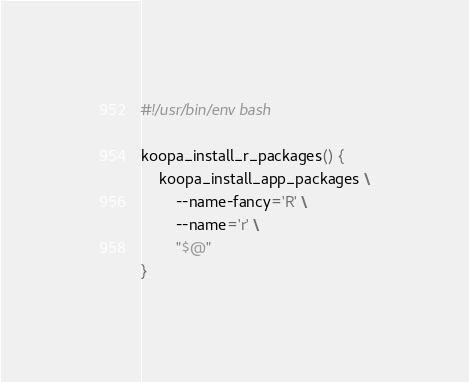Convert code to text. <code><loc_0><loc_0><loc_500><loc_500><_Bash_>#!/usr/bin/env bash

koopa_install_r_packages() {
    koopa_install_app_packages \
        --name-fancy='R' \
        --name='r' \
        "$@"
}
</code> 